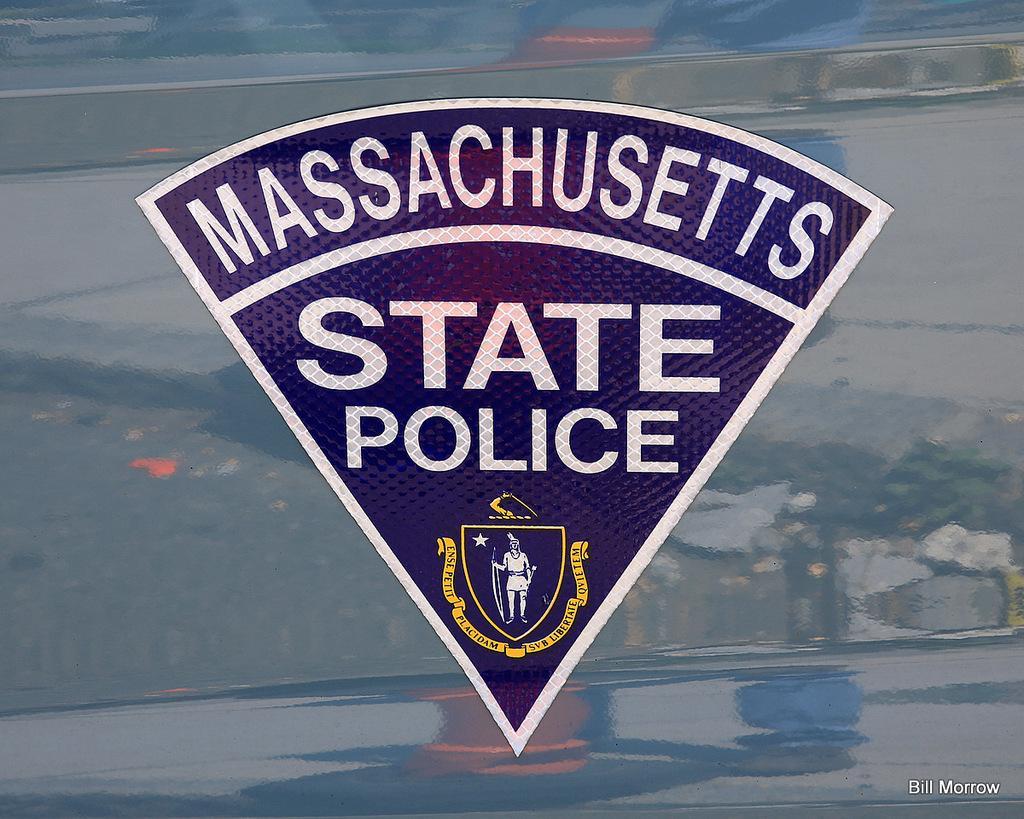Describe this image in one or two sentences. In the center of the image we can see a logo with some text. In the background the image is blur. In the bottom right corner we can see some text. 